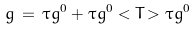Convert formula to latex. <formula><loc_0><loc_0><loc_500><loc_500>g \, = \, \tau g ^ { 0 } + \tau g ^ { 0 } < T > \tau g ^ { 0 }</formula> 